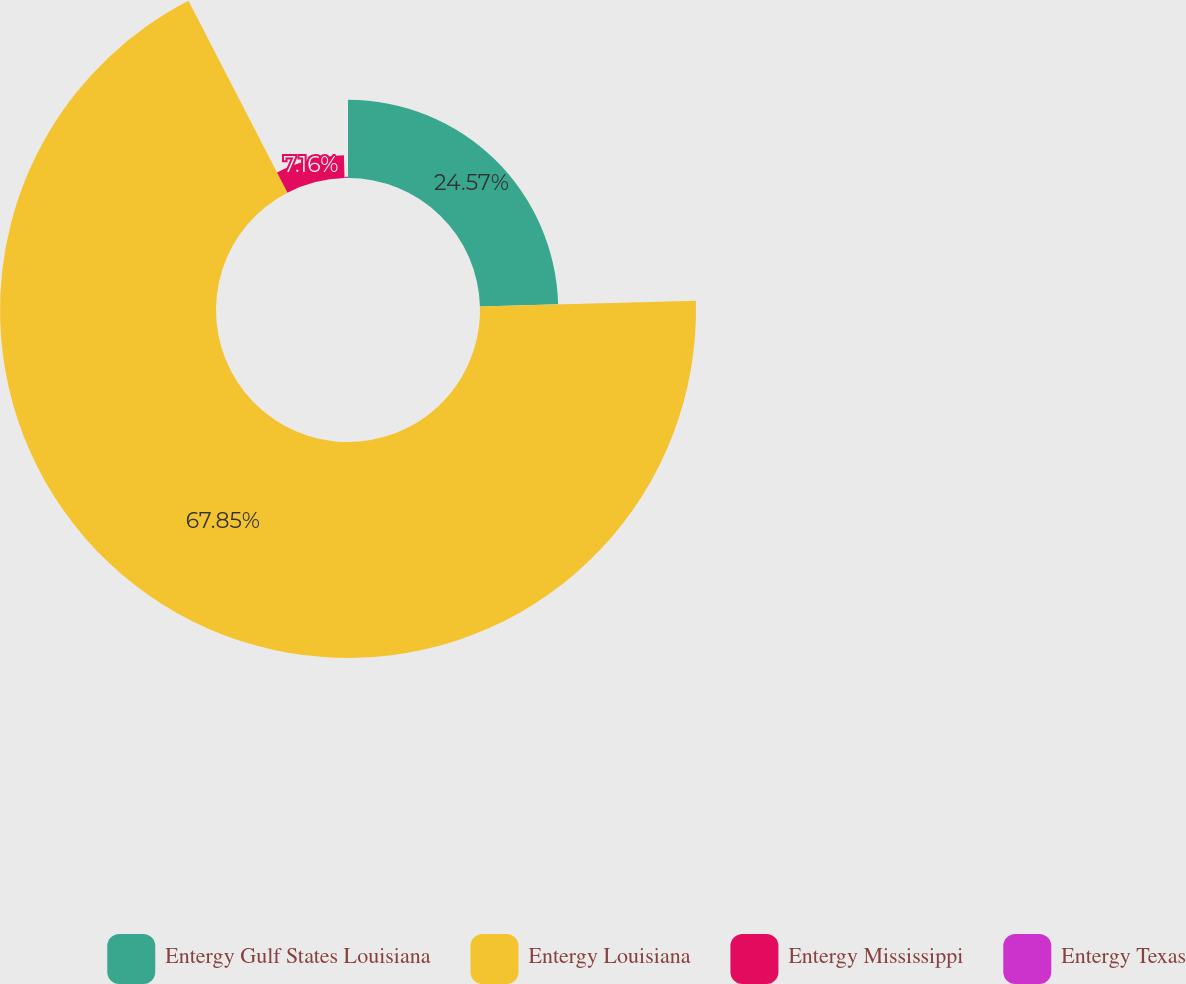Convert chart. <chart><loc_0><loc_0><loc_500><loc_500><pie_chart><fcel>Entergy Gulf States Louisiana<fcel>Entergy Louisiana<fcel>Entergy Mississippi<fcel>Entergy Texas<nl><fcel>24.57%<fcel>67.84%<fcel>7.16%<fcel>0.42%<nl></chart> 